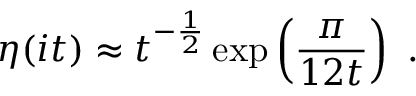<formula> <loc_0><loc_0><loc_500><loc_500>\eta ( i t ) \approx t ^ { - \frac { 1 } { 2 } } \exp \left ( \frac { \pi } { 1 2 t } \right ) .</formula> 